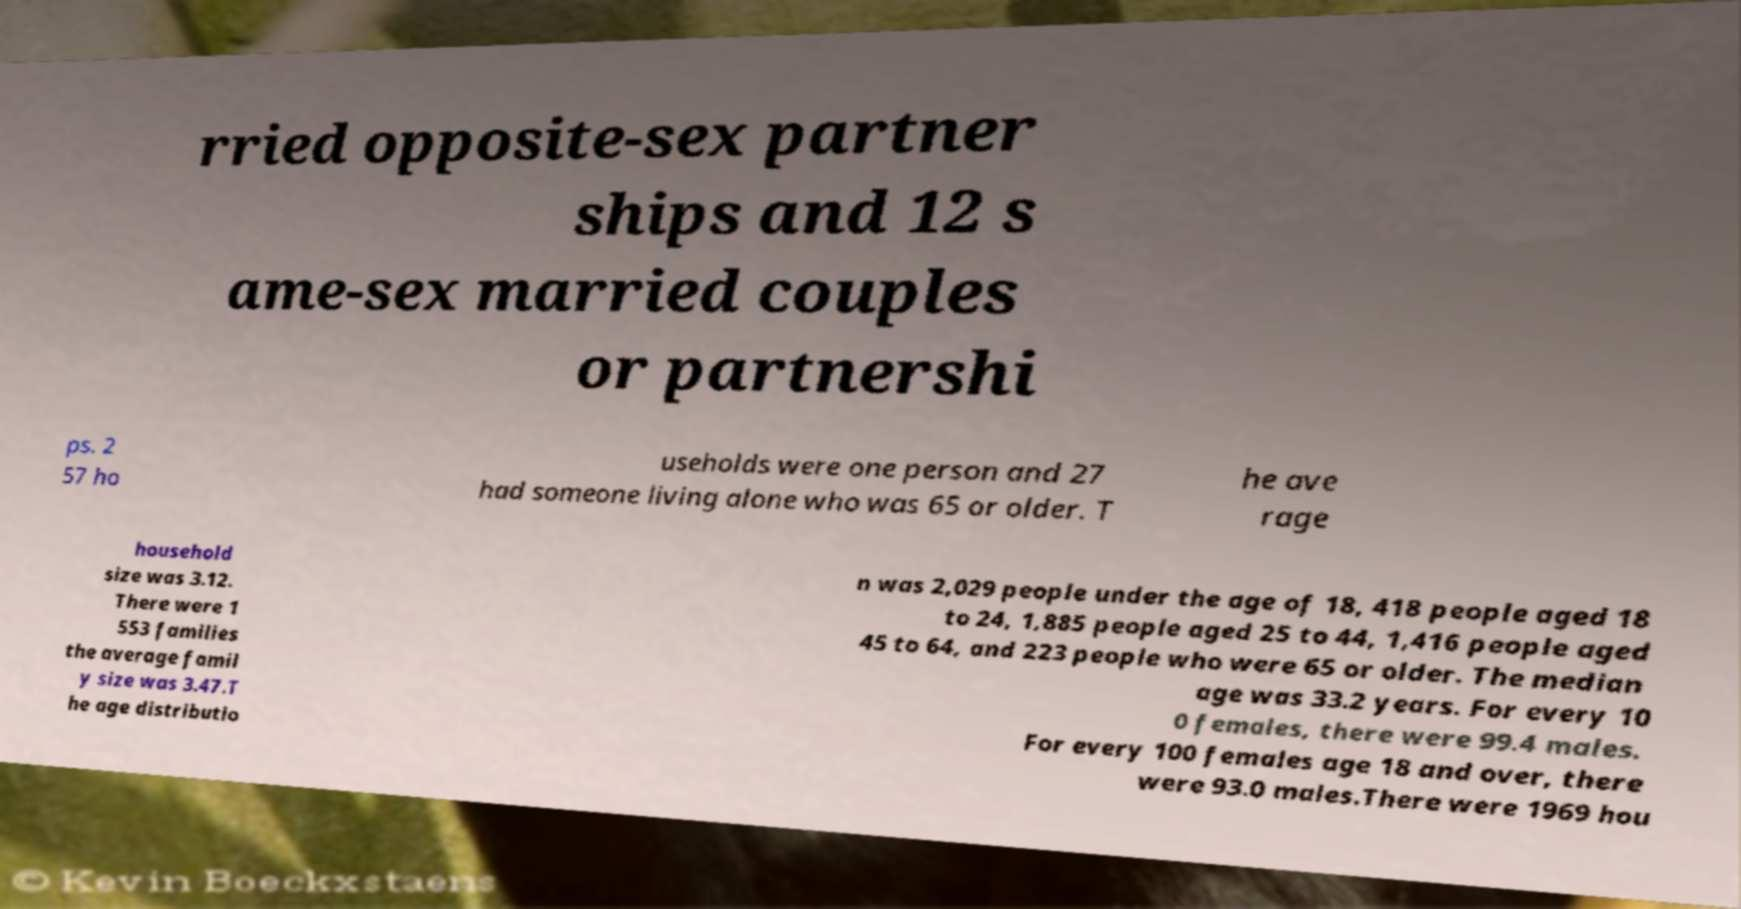What messages or text are displayed in this image? I need them in a readable, typed format. rried opposite-sex partner ships and 12 s ame-sex married couples or partnershi ps. 2 57 ho useholds were one person and 27 had someone living alone who was 65 or older. T he ave rage household size was 3.12. There were 1 553 families the average famil y size was 3.47.T he age distributio n was 2,029 people under the age of 18, 418 people aged 18 to 24, 1,885 people aged 25 to 44, 1,416 people aged 45 to 64, and 223 people who were 65 or older. The median age was 33.2 years. For every 10 0 females, there were 99.4 males. For every 100 females age 18 and over, there were 93.0 males.There were 1969 hou 